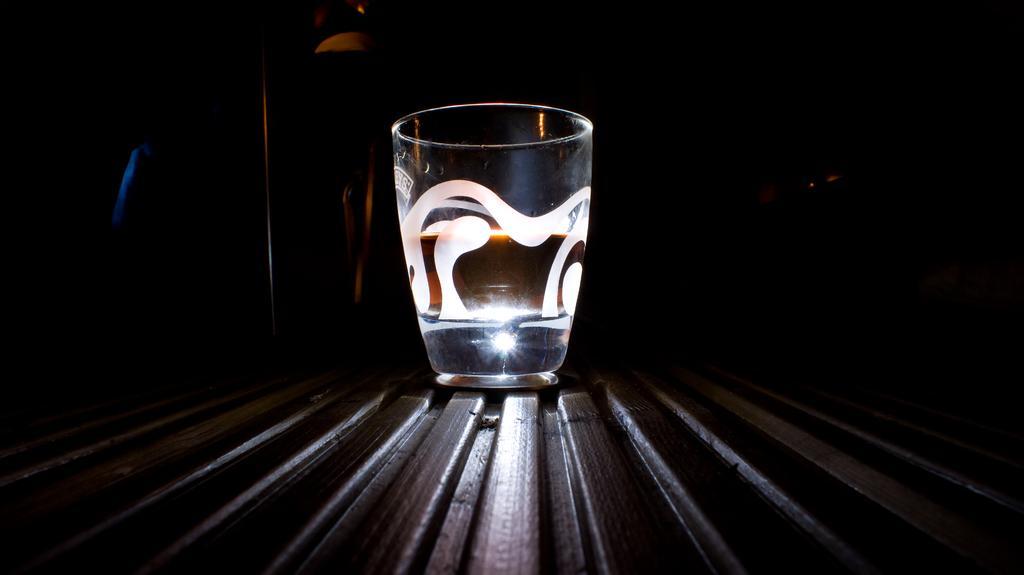In one or two sentences, can you explain what this image depicts? In this image we can see a glass on a surface. The background of the image is dark. 